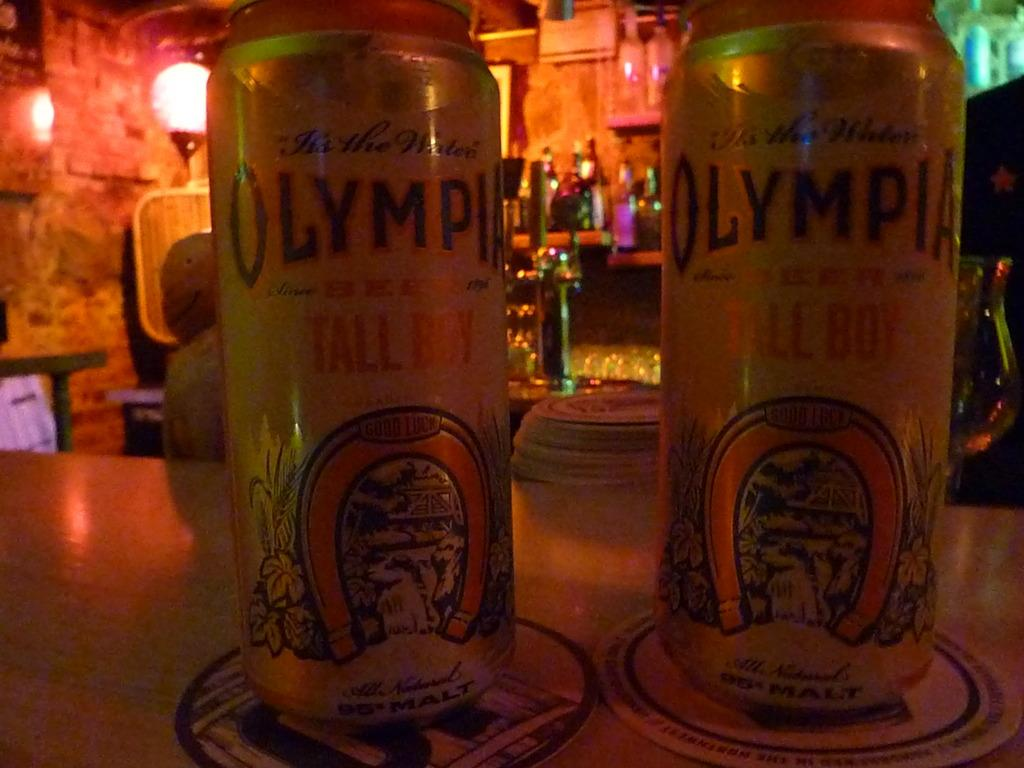<image>
Provide a brief description of the given image. Two cans of Olympia beer sit on a bar in dark lighting. 